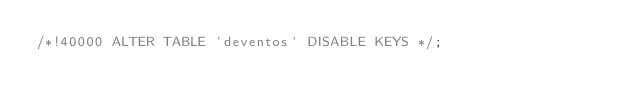<code> <loc_0><loc_0><loc_500><loc_500><_SQL_>/*!40000 ALTER TABLE `deventos` DISABLE KEYS */;</code> 